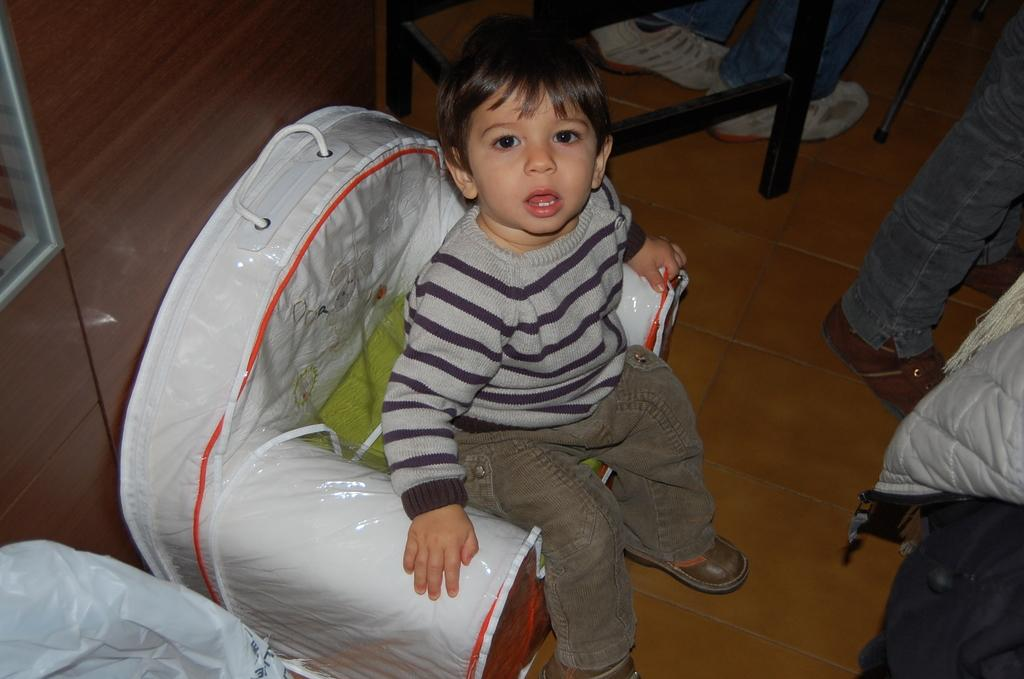What is the boy in the image doing? The boy is sitting on a chair in the image. What is located near the boy? There is a table beside the boy. Whose legs are visible in the image? Some person's legs are visible in the image. What type of clothing is present in the image? There is a jacket in the image. What is covering the surface of the table? There is a plastic cover in the image. What can be seen in the background of the image? There is a wall in the background of the image. How many trees are growing on the wall in the image? There are no trees visible on the wall in the image. What type of needle is being used to sew the jacket in the image? There is no needle present in the image, and the jacket is not being sewn. 